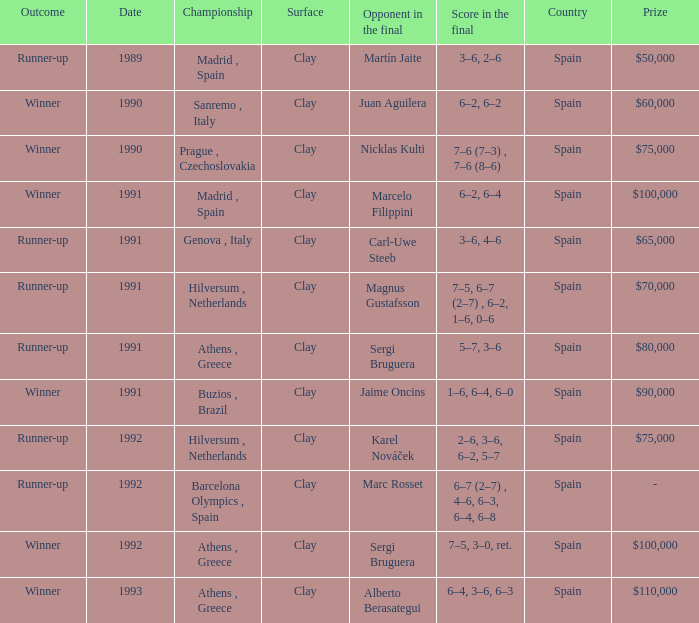What is Opponent In The Final, when Date is before 1991, and when Outcome is "Runner-Up"? Martín Jaite. 